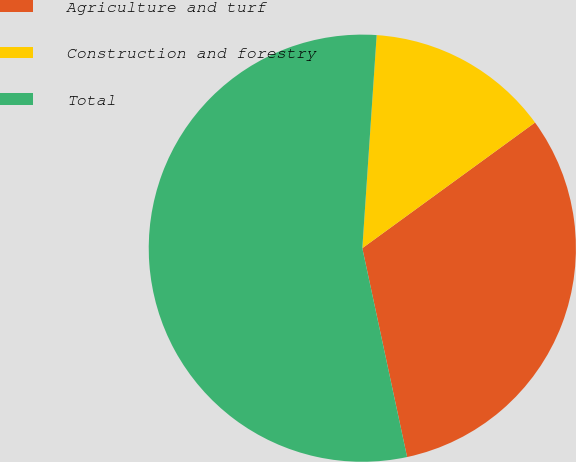Convert chart to OTSL. <chart><loc_0><loc_0><loc_500><loc_500><pie_chart><fcel>Agriculture and turf<fcel>Construction and forestry<fcel>Total<nl><fcel>31.65%<fcel>13.92%<fcel>54.43%<nl></chart> 